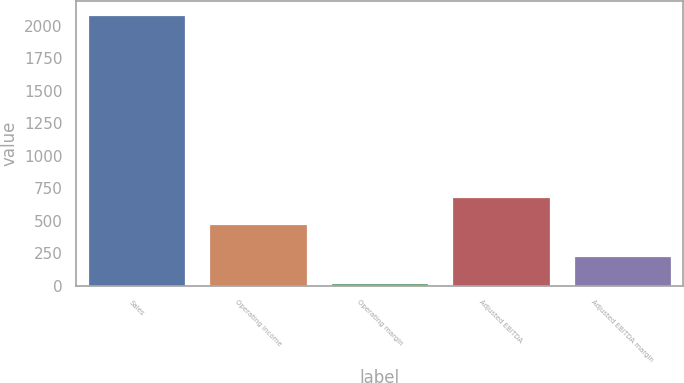Convert chart to OTSL. <chart><loc_0><loc_0><loc_500><loc_500><bar_chart><fcel>Sales<fcel>Operating income<fcel>Operating margin<fcel>Adjusted EBITDA<fcel>Adjusted EBITDA margin<nl><fcel>2087.1<fcel>476.7<fcel>22.8<fcel>683.13<fcel>229.23<nl></chart> 